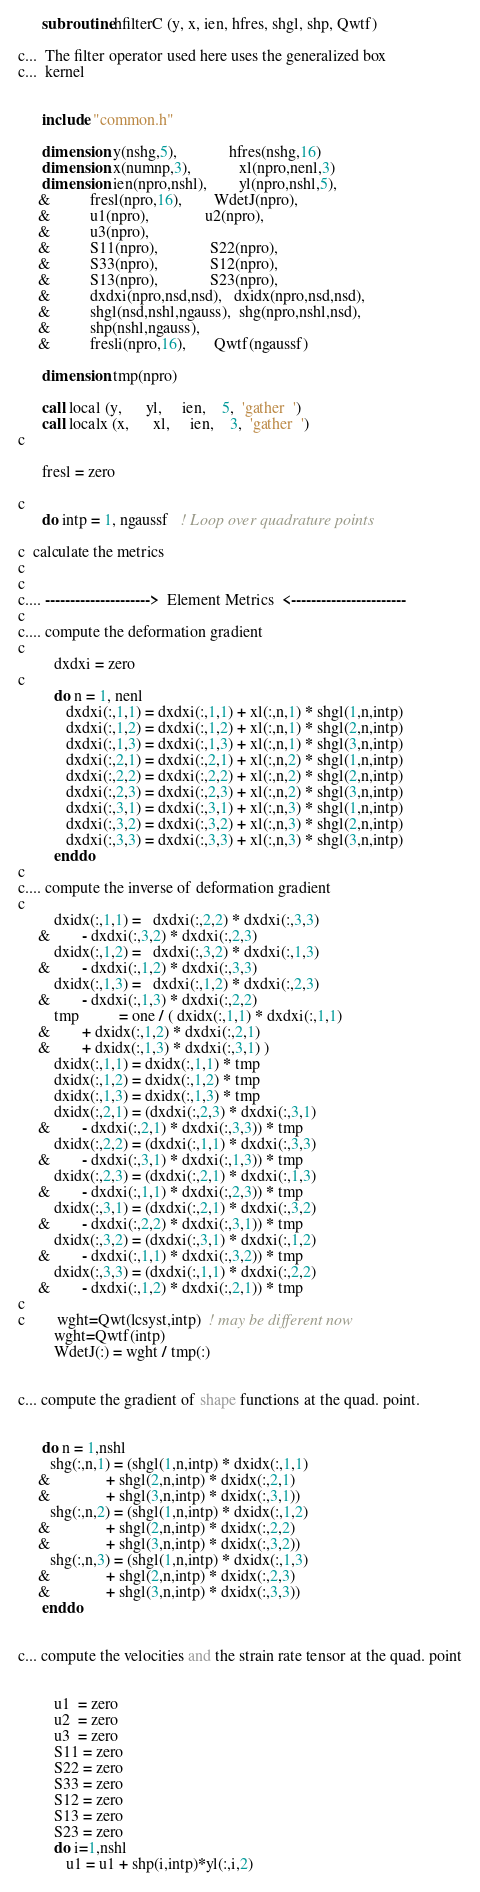Convert code to text. <code><loc_0><loc_0><loc_500><loc_500><_FORTRAN_>      subroutine hfilterC (y, x, ien, hfres, shgl, shp, Qwtf)

c...  The filter operator used here uses the generalized box 
c...  kernel


      include "common.h"

      dimension y(nshg,5),             hfres(nshg,16)
      dimension x(numnp,3),            xl(npro,nenl,3)
      dimension ien(npro,nshl),        yl(npro,nshl,5),
     &          fresl(npro,16),        WdetJ(npro),
     &          u1(npro),              u2(npro),
     &          u3(npro),              
     &          S11(npro),             S22(npro),
     &          S33(npro),             S12(npro),
     &          S13(npro),             S23(npro),
     &          dxdxi(npro,nsd,nsd),   dxidx(npro,nsd,nsd),
     &          shgl(nsd,nshl,ngauss),  shg(npro,nshl,nsd),
     &          shp(nshl,ngauss),       
     &          fresli(npro,16),       Qwtf(ngaussf)

      dimension tmp(npro)

      call local (y,      yl,     ien,    5,  'gather  ')
      call localx (x,      xl,     ien,    3,  'gather  ')
c

      fresl = zero

c
      do intp = 1, ngaussf   ! Loop over quadrature points

c  calculate the metrics
c
c
c.... --------------------->  Element Metrics  <-----------------------
c
c.... compute the deformation gradient
c
         dxdxi = zero
c
         do n = 1, nenl
            dxdxi(:,1,1) = dxdxi(:,1,1) + xl(:,n,1) * shgl(1,n,intp)
            dxdxi(:,1,2) = dxdxi(:,1,2) + xl(:,n,1) * shgl(2,n,intp)
            dxdxi(:,1,3) = dxdxi(:,1,3) + xl(:,n,1) * shgl(3,n,intp)
            dxdxi(:,2,1) = dxdxi(:,2,1) + xl(:,n,2) * shgl(1,n,intp)
            dxdxi(:,2,2) = dxdxi(:,2,2) + xl(:,n,2) * shgl(2,n,intp)
            dxdxi(:,2,3) = dxdxi(:,2,3) + xl(:,n,2) * shgl(3,n,intp)
            dxdxi(:,3,1) = dxdxi(:,3,1) + xl(:,n,3) * shgl(1,n,intp)
            dxdxi(:,3,2) = dxdxi(:,3,2) + xl(:,n,3) * shgl(2,n,intp)
            dxdxi(:,3,3) = dxdxi(:,3,3) + xl(:,n,3) * shgl(3,n,intp)
         enddo
c     
c.... compute the inverse of deformation gradient
c
         dxidx(:,1,1) =   dxdxi(:,2,2) * dxdxi(:,3,3)
     &        - dxdxi(:,3,2) * dxdxi(:,2,3)
         dxidx(:,1,2) =   dxdxi(:,3,2) * dxdxi(:,1,3)
     &        - dxdxi(:,1,2) * dxdxi(:,3,3)
         dxidx(:,1,3) =   dxdxi(:,1,2) * dxdxi(:,2,3)
     &        - dxdxi(:,1,3) * dxdxi(:,2,2)
         tmp          = one / ( dxidx(:,1,1) * dxdxi(:,1,1)
     &        + dxidx(:,1,2) * dxdxi(:,2,1)
     &        + dxidx(:,1,3) * dxdxi(:,3,1) )
         dxidx(:,1,1) = dxidx(:,1,1) * tmp
         dxidx(:,1,2) = dxidx(:,1,2) * tmp
         dxidx(:,1,3) = dxidx(:,1,3) * tmp
         dxidx(:,2,1) = (dxdxi(:,2,3) * dxdxi(:,3,1)
     &        - dxdxi(:,2,1) * dxdxi(:,3,3)) * tmp
         dxidx(:,2,2) = (dxdxi(:,1,1) * dxdxi(:,3,3)
     &        - dxdxi(:,3,1) * dxdxi(:,1,3)) * tmp
         dxidx(:,2,3) = (dxdxi(:,2,1) * dxdxi(:,1,3)
     &        - dxdxi(:,1,1) * dxdxi(:,2,3)) * tmp
         dxidx(:,3,1) = (dxdxi(:,2,1) * dxdxi(:,3,2)
     &        - dxdxi(:,2,2) * dxdxi(:,3,1)) * tmp
         dxidx(:,3,2) = (dxdxi(:,3,1) * dxdxi(:,1,2)
     &        - dxdxi(:,1,1) * dxdxi(:,3,2)) * tmp
         dxidx(:,3,3) = (dxdxi(:,1,1) * dxdxi(:,2,2)
     &        - dxdxi(:,1,2) * dxdxi(:,2,1)) * tmp
c     
c        wght=Qwt(lcsyst,intp)  ! may be different now
         wght=Qwtf(intp)         
         WdetJ(:) = wght / tmp(:)
         

c... compute the gradient of shape functions at the quad. point.


      do n = 1,nshl 
        shg(:,n,1) = (shgl(1,n,intp) * dxidx(:,1,1)
     &              + shgl(2,n,intp) * dxidx(:,2,1)
     &              + shgl(3,n,intp) * dxidx(:,3,1))
        shg(:,n,2) = (shgl(1,n,intp) * dxidx(:,1,2)
     &              + shgl(2,n,intp) * dxidx(:,2,2)
     &              + shgl(3,n,intp) * dxidx(:,3,2))
        shg(:,n,3) = (shgl(1,n,intp) * dxidx(:,1,3)
     &              + shgl(2,n,intp) * dxidx(:,2,3)
     &              + shgl(3,n,intp) * dxidx(:,3,3))
      enddo


c... compute the velocities and the strain rate tensor at the quad. point


         u1  = zero
         u2  = zero
         u3  = zero
         S11 = zero
         S22 = zero
         S33 = zero
         S12 = zero
         S13 = zero
         S23 = zero
         do i=1,nshl  
            u1 = u1 + shp(i,intp)*yl(:,i,2)</code> 